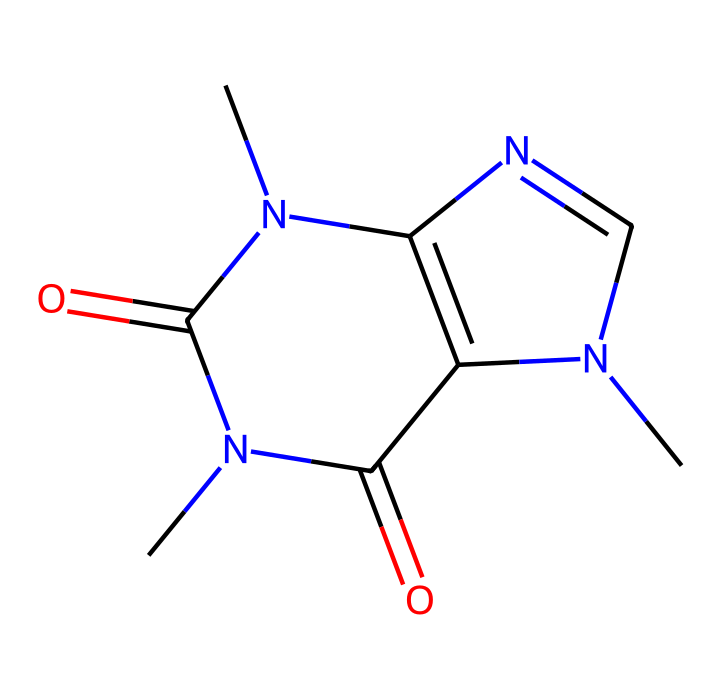What is the molecular formula of caffeine? To determine the molecular formula, we need to count the number of each type of atom present in the SMILES representation. The given SMILES indicates that there are 8 carbon atoms, 10 hydrogen atoms, 4 nitrogen atoms, and 2 oxygen atoms. Thus, the molecular formula is C8H10N4O2.
Answer: C8H10N4O2 How many nitrogen atoms are in caffeine? By examining the SMILES representation, we can see that there are four nitrogen atoms present in the structure of caffeine.
Answer: 4 Is caffeine an aromatic compound? Caffeine contains a structure that includes nitrogen atoms within a cyclic arrangement, and this cyclic structure refers to its aromatic nature as it meets the criteria of aromatic compounds, including resonance.
Answer: Yes What is the significance of nitrogen in caffeine's structure? The presence of nitrogen in caffeine's structure indicates that it is an alkaloid, contributing to its physiological effects, such as acting as a stimulant by antagonizing adenosine receptors in the brain.
Answer: Stimulant What type of functional groups are present in caffeine? By analyzing the structure, we can identify that caffeine contains both amide (due to the carbonyl attached to nitrogen) and imine functional groups, which are characteristic of its chemical behavior.
Answer: Amide, imine Does caffeine have any resonance structures? Evaluating caffeine's structure, we see that the cyclic nature and alternating double bonds allow the distribution of electron density across the molecule, indicating multiple resonance forms due to delocalization of electrons.
Answer: Yes 